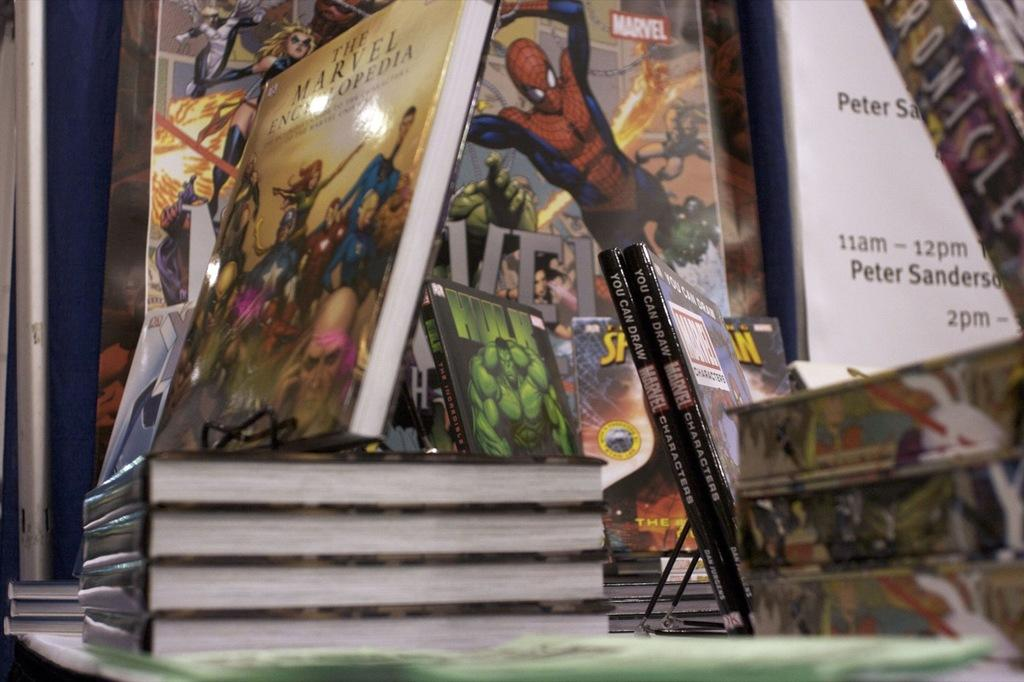<image>
Write a terse but informative summary of the picture. a collection of books on display, several are from Marvel. 